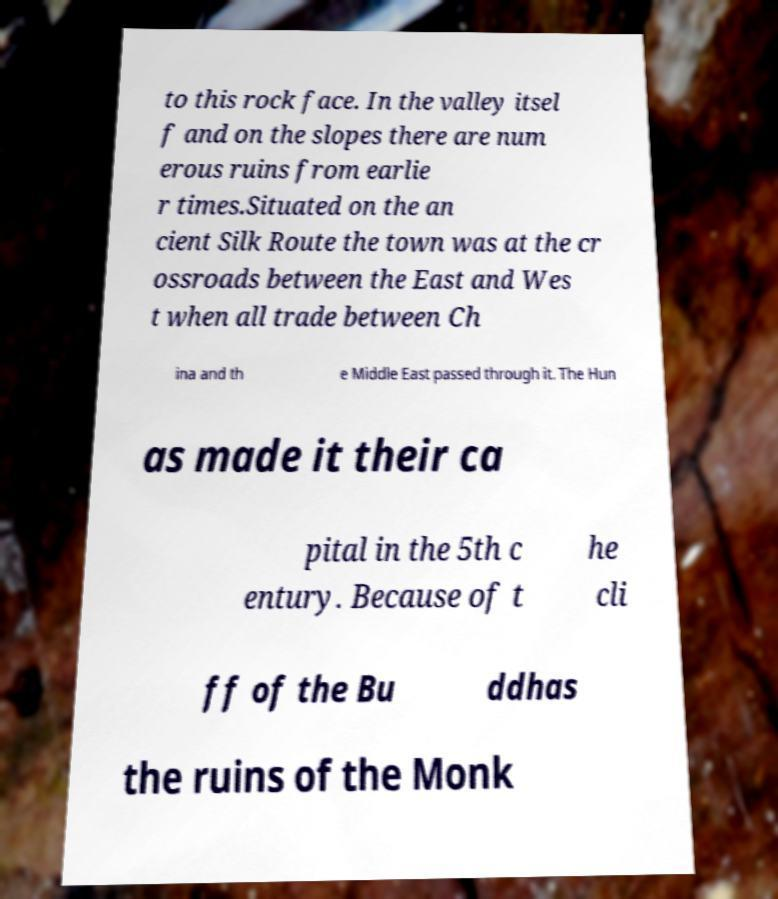Can you read and provide the text displayed in the image?This photo seems to have some interesting text. Can you extract and type it out for me? to this rock face. In the valley itsel f and on the slopes there are num erous ruins from earlie r times.Situated on the an cient Silk Route the town was at the cr ossroads between the East and Wes t when all trade between Ch ina and th e Middle East passed through it. The Hun as made it their ca pital in the 5th c entury. Because of t he cli ff of the Bu ddhas the ruins of the Monk 